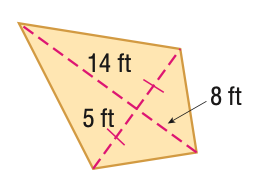Answer the mathemtical geometry problem and directly provide the correct option letter.
Question: Find the area of the kite.
Choices: A: 40 B: 70 C: 110 D: 220 C 